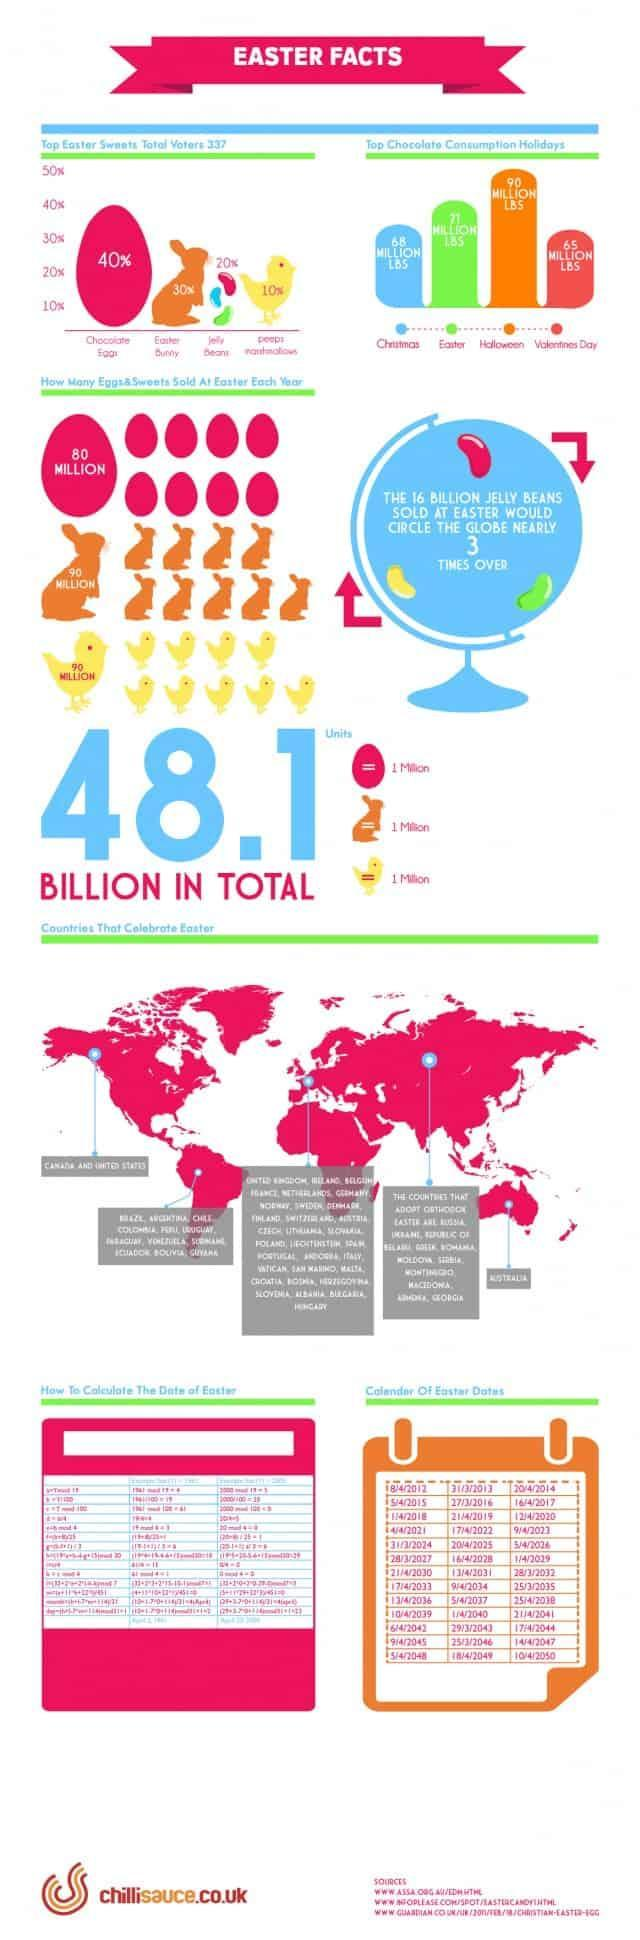How many Easter Bunny are sold every Easter?
Answer the question with a short phrase. 90 MILLION On which day of April Easter will be celebrated on 2030? 21 Which day is considered as the second most consumption day of Chocolate? Easter How many Peeps marshmallows are sold every Easter? 90 million Which is the island found in the eastern most region of the map? Australia Which is the second most used Easter sweet? Easter Bunny On which day of April Easter will be celebrated on 2044? 17 How many jelly beans are shown in the infographic? 3 On which month Easter will be celebrated on 2032- March, April, May, June? March 